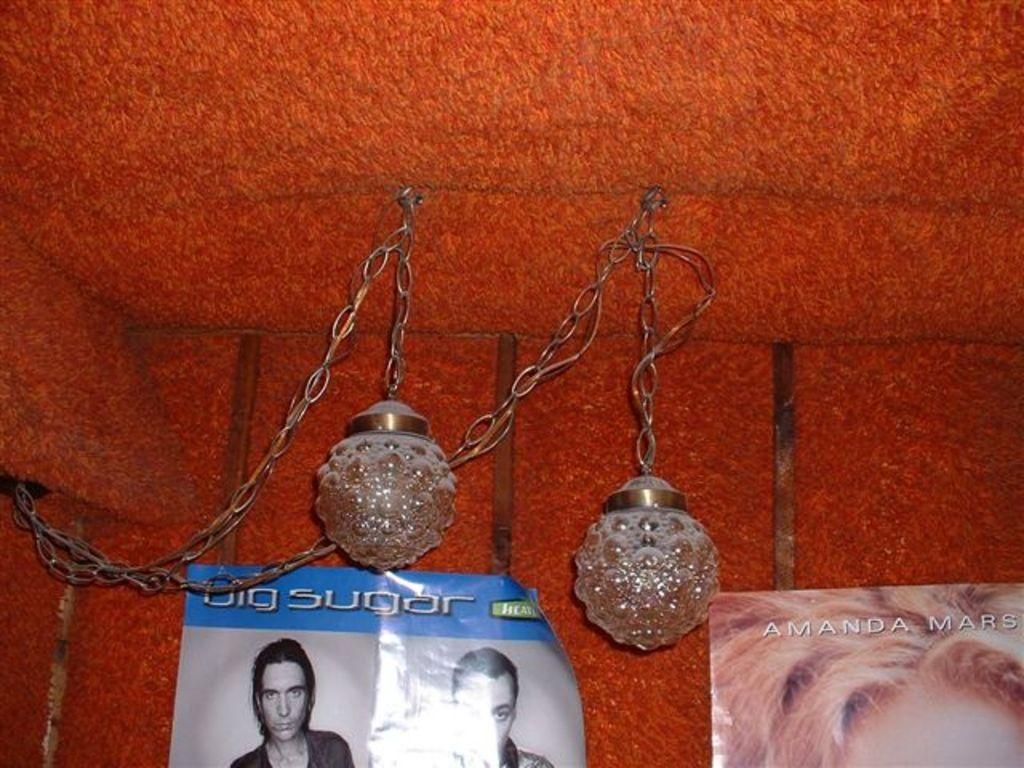What type of lighting fixtures are present in the image? There are lamps in the image. What other objects can be seen in the image? There are chains and two posters on the wall in the image. What type of tent is set up in the image? There is no tent present in the image. What color is the eggnog being served in the image? There is no eggnog present in the image. 